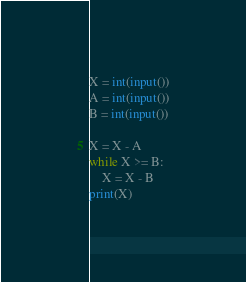<code> <loc_0><loc_0><loc_500><loc_500><_Python_>X = int(input())
A = int(input())
B = int(input())

X = X - A
while X >= B:
    X = X - B
print(X)</code> 